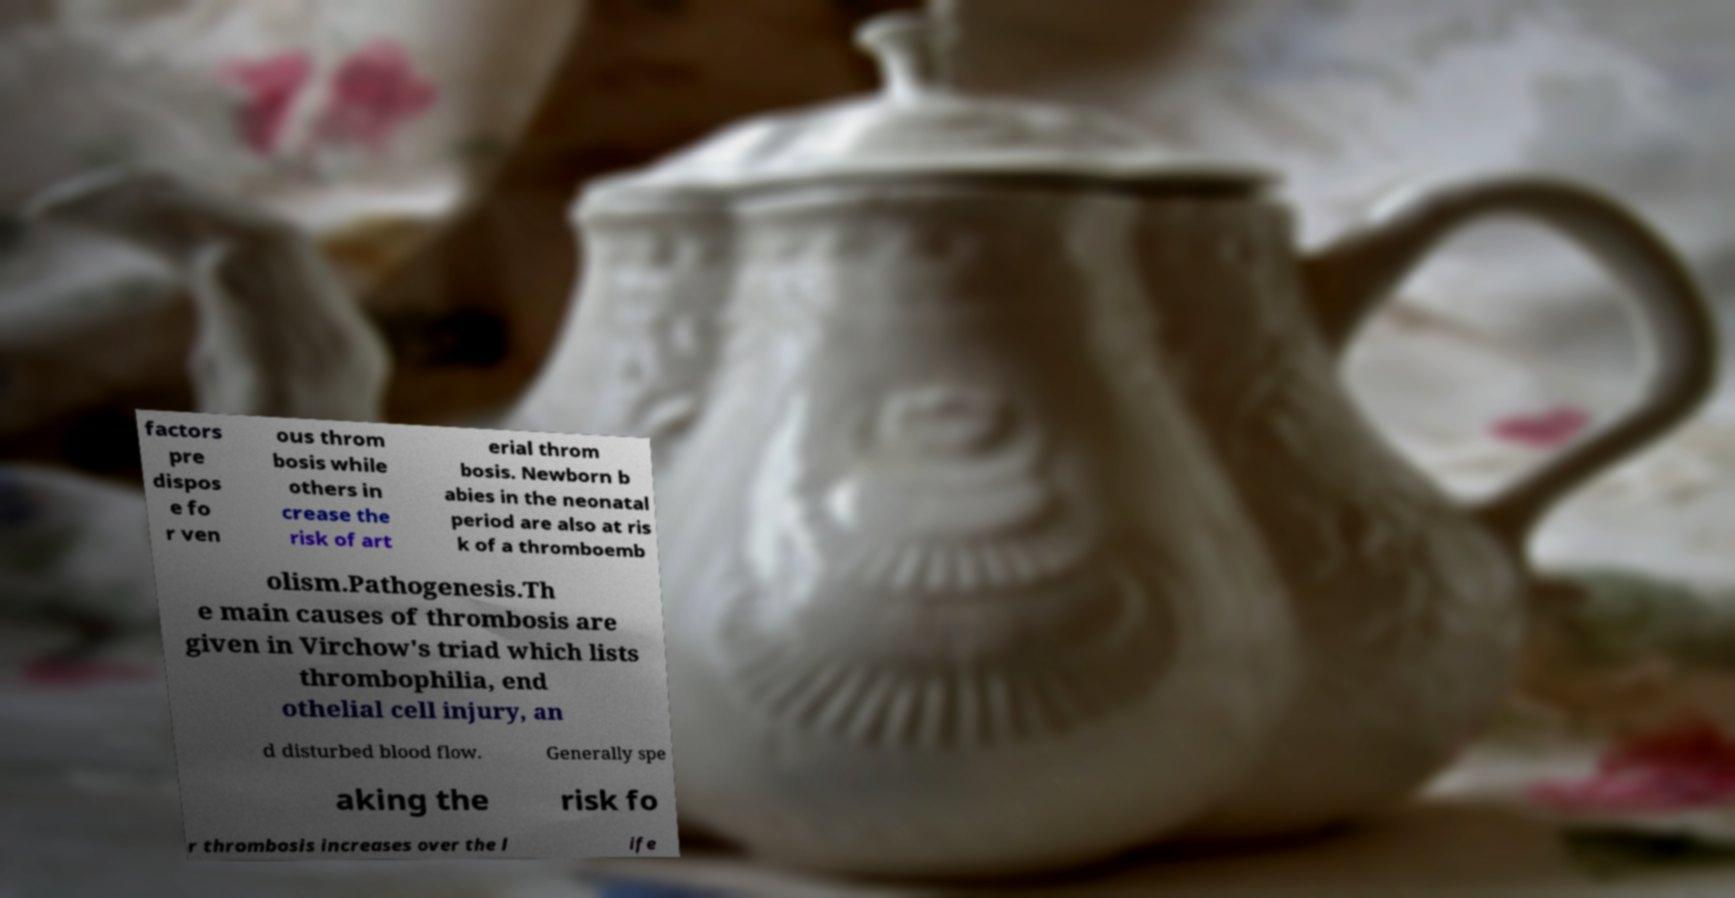Could you assist in decoding the text presented in this image and type it out clearly? factors pre dispos e fo r ven ous throm bosis while others in crease the risk of art erial throm bosis. Newborn b abies in the neonatal period are also at ris k of a thromboemb olism.Pathogenesis.Th e main causes of thrombosis are given in Virchow's triad which lists thrombophilia, end othelial cell injury, an d disturbed blood flow. Generally spe aking the risk fo r thrombosis increases over the l ife 